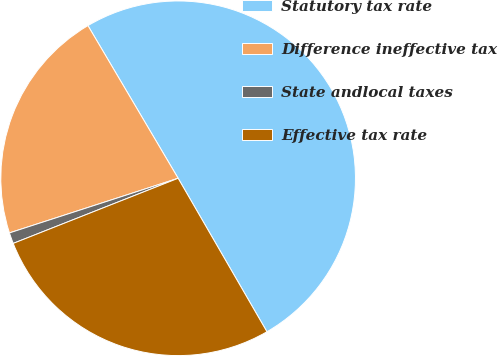<chart> <loc_0><loc_0><loc_500><loc_500><pie_chart><fcel>Statutory tax rate<fcel>Difference ineffective tax<fcel>State andlocal taxes<fcel>Effective tax rate<nl><fcel>50.14%<fcel>21.49%<fcel>1.0%<fcel>27.36%<nl></chart> 